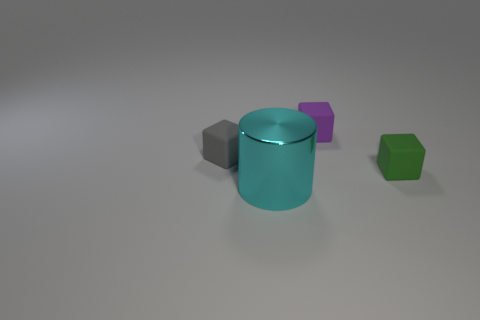Is the material of the small gray thing the same as the big cylinder?
Your answer should be compact. No. What shape is the small rubber thing in front of the tiny block left of the object in front of the green rubber cube?
Provide a succinct answer. Cube. Is the number of large things that are to the left of the small gray matte cube less than the number of things that are on the left side of the large cylinder?
Your answer should be compact. Yes. There is a matte object to the left of the tiny cube that is behind the tiny gray matte object; what is its shape?
Provide a succinct answer. Cube. Is there any other thing that is the same color as the big shiny cylinder?
Provide a succinct answer. No. What number of purple objects are either metal cylinders or matte objects?
Give a very brief answer. 1. Is the number of small purple cubes to the left of the gray thing less than the number of green cubes?
Keep it short and to the point. Yes. There is a rubber cube that is behind the tiny gray matte block; how many large objects are behind it?
Give a very brief answer. 0. How many other objects are the same size as the green rubber object?
Your answer should be very brief. 2. What number of objects are either large green metal objects or rubber blocks on the right side of the small gray matte cube?
Offer a very short reply. 2. 